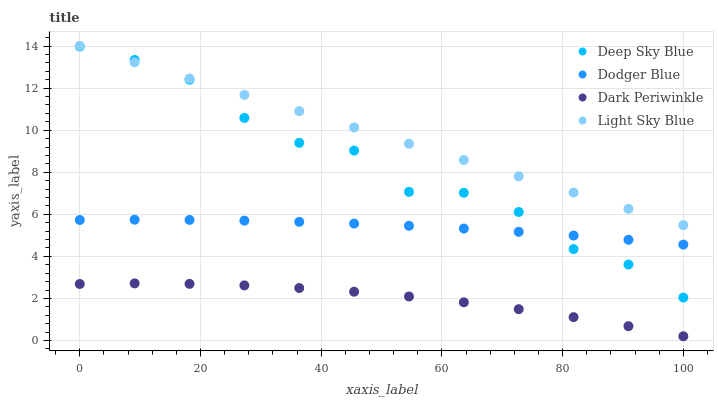Does Dark Periwinkle have the minimum area under the curve?
Answer yes or no. Yes. Does Light Sky Blue have the maximum area under the curve?
Answer yes or no. Yes. Does Dodger Blue have the minimum area under the curve?
Answer yes or no. No. Does Dodger Blue have the maximum area under the curve?
Answer yes or no. No. Is Light Sky Blue the smoothest?
Answer yes or no. Yes. Is Deep Sky Blue the roughest?
Answer yes or no. Yes. Is Dodger Blue the smoothest?
Answer yes or no. No. Is Dodger Blue the roughest?
Answer yes or no. No. Does Dark Periwinkle have the lowest value?
Answer yes or no. Yes. Does Dodger Blue have the lowest value?
Answer yes or no. No. Does Light Sky Blue have the highest value?
Answer yes or no. Yes. Does Dodger Blue have the highest value?
Answer yes or no. No. Is Dark Periwinkle less than Deep Sky Blue?
Answer yes or no. Yes. Is Deep Sky Blue greater than Dark Periwinkle?
Answer yes or no. Yes. Does Dodger Blue intersect Deep Sky Blue?
Answer yes or no. Yes. Is Dodger Blue less than Deep Sky Blue?
Answer yes or no. No. Is Dodger Blue greater than Deep Sky Blue?
Answer yes or no. No. Does Dark Periwinkle intersect Deep Sky Blue?
Answer yes or no. No. 